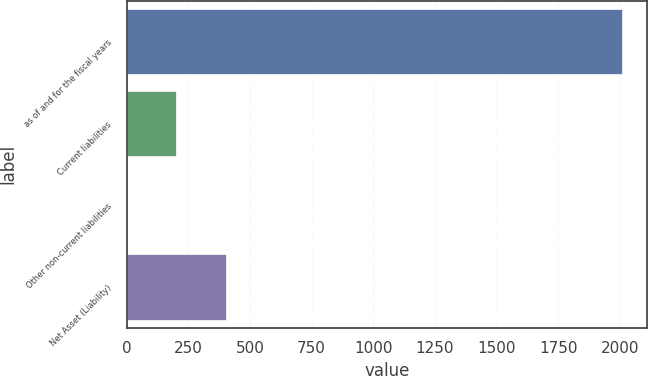<chart> <loc_0><loc_0><loc_500><loc_500><bar_chart><fcel>as of and for the fiscal years<fcel>Current liabilities<fcel>Other non-current liabilities<fcel>Net Asset (Liability)<nl><fcel>2009<fcel>201.13<fcel>0.26<fcel>402<nl></chart> 